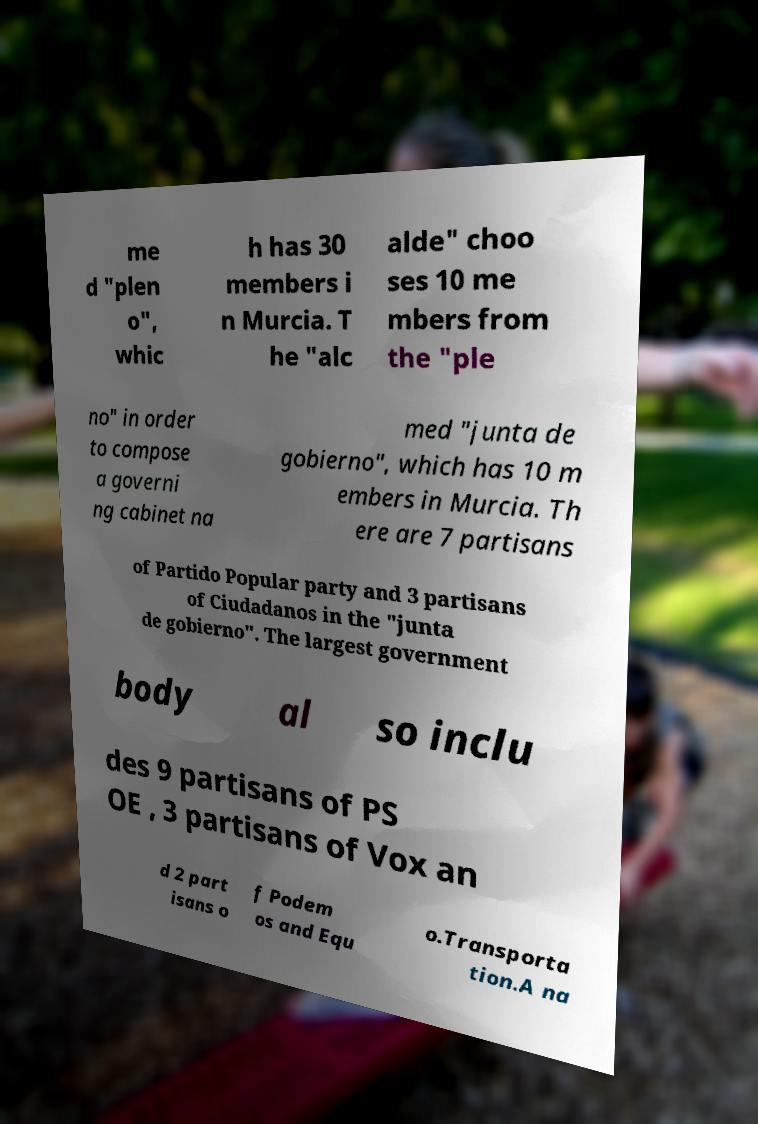Can you read and provide the text displayed in the image?This photo seems to have some interesting text. Can you extract and type it out for me? me d "plen o", whic h has 30 members i n Murcia. T he "alc alde" choo ses 10 me mbers from the "ple no" in order to compose a governi ng cabinet na med "junta de gobierno", which has 10 m embers in Murcia. Th ere are 7 partisans of Partido Popular party and 3 partisans of Ciudadanos in the "junta de gobierno". The largest government body al so inclu des 9 partisans of PS OE , 3 partisans of Vox an d 2 part isans o f Podem os and Equ o.Transporta tion.A na 